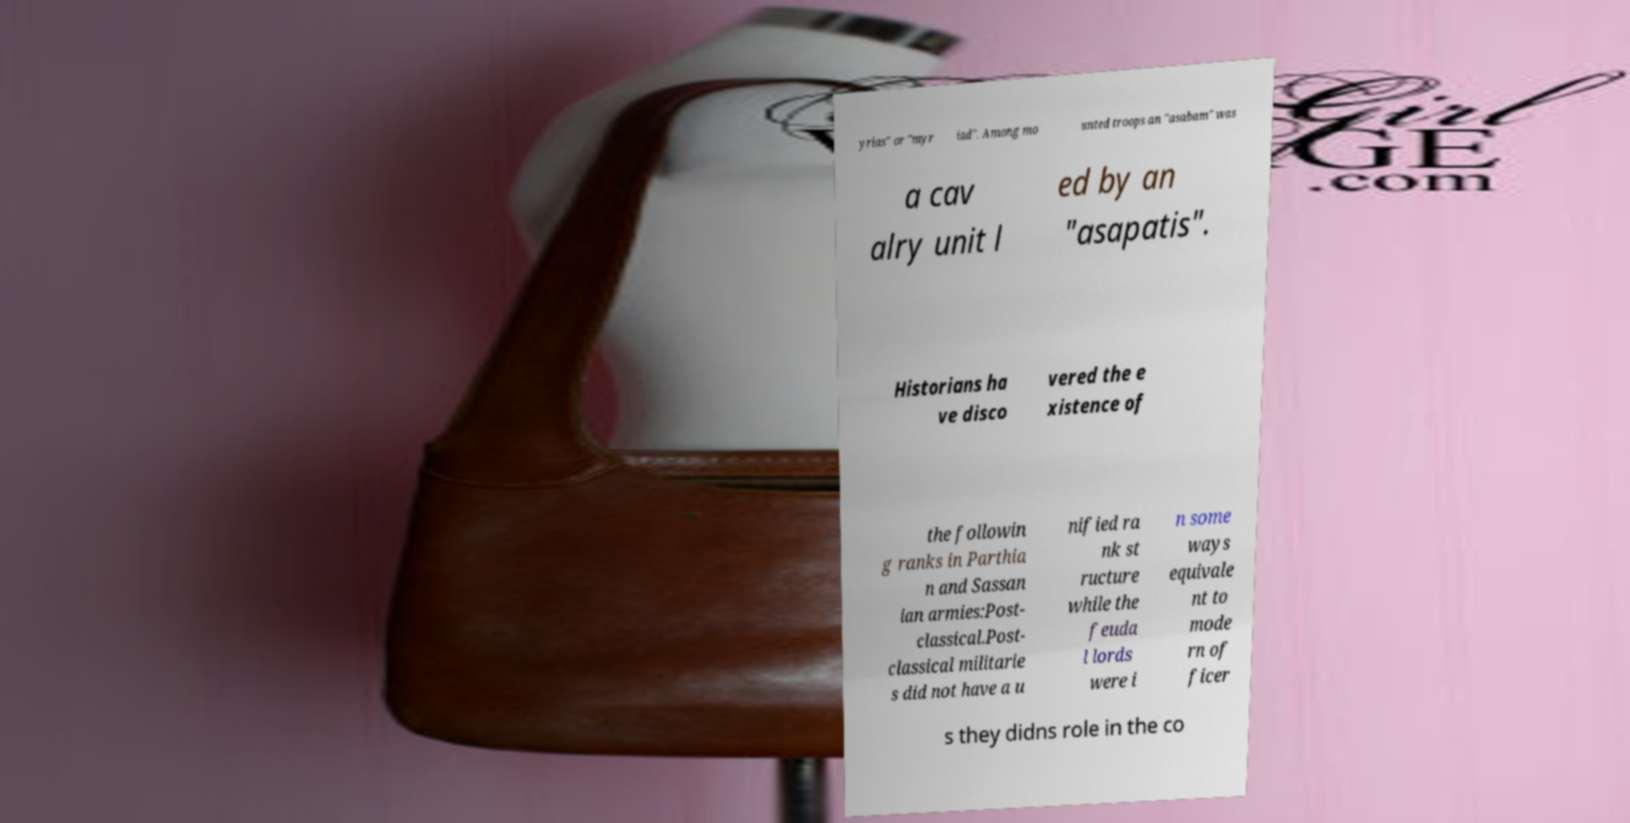Could you assist in decoding the text presented in this image and type it out clearly? yrias" or "myr iad". Among mo unted troops an "asabam" was a cav alry unit l ed by an "asapatis". Historians ha ve disco vered the e xistence of the followin g ranks in Parthia n and Sassan ian armies:Post- classical.Post- classical militarie s did not have a u nified ra nk st ructure while the feuda l lords were i n some ways equivale nt to mode rn of ficer s they didns role in the co 